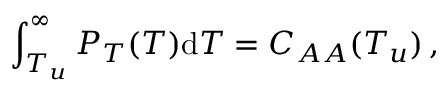<formula> <loc_0><loc_0><loc_500><loc_500>\int _ { T _ { u } } ^ { \infty } P _ { T } ( T ) d T = C _ { A A } ( T _ { u } ) \, ,</formula> 